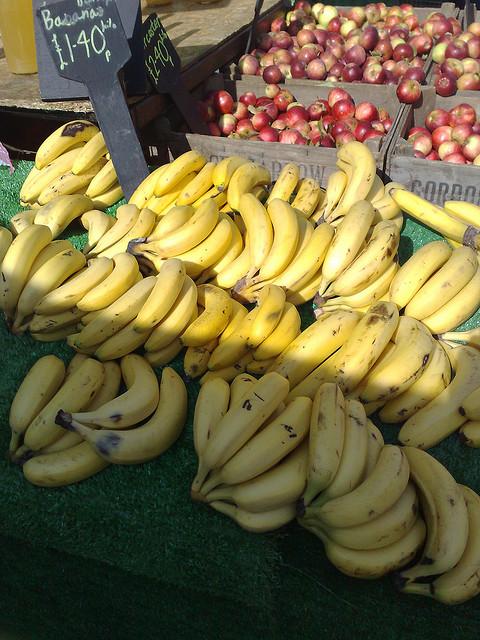Are all the bananas yellow?
Concise answer only. Yes. Where are the bananas?
Be succinct. Table. Are the bananas ripe?
Write a very short answer. Yes. Are those watermelons?
Concise answer only. No. How many types of fruit are displayed in the photo?
Quick response, please. 2. 